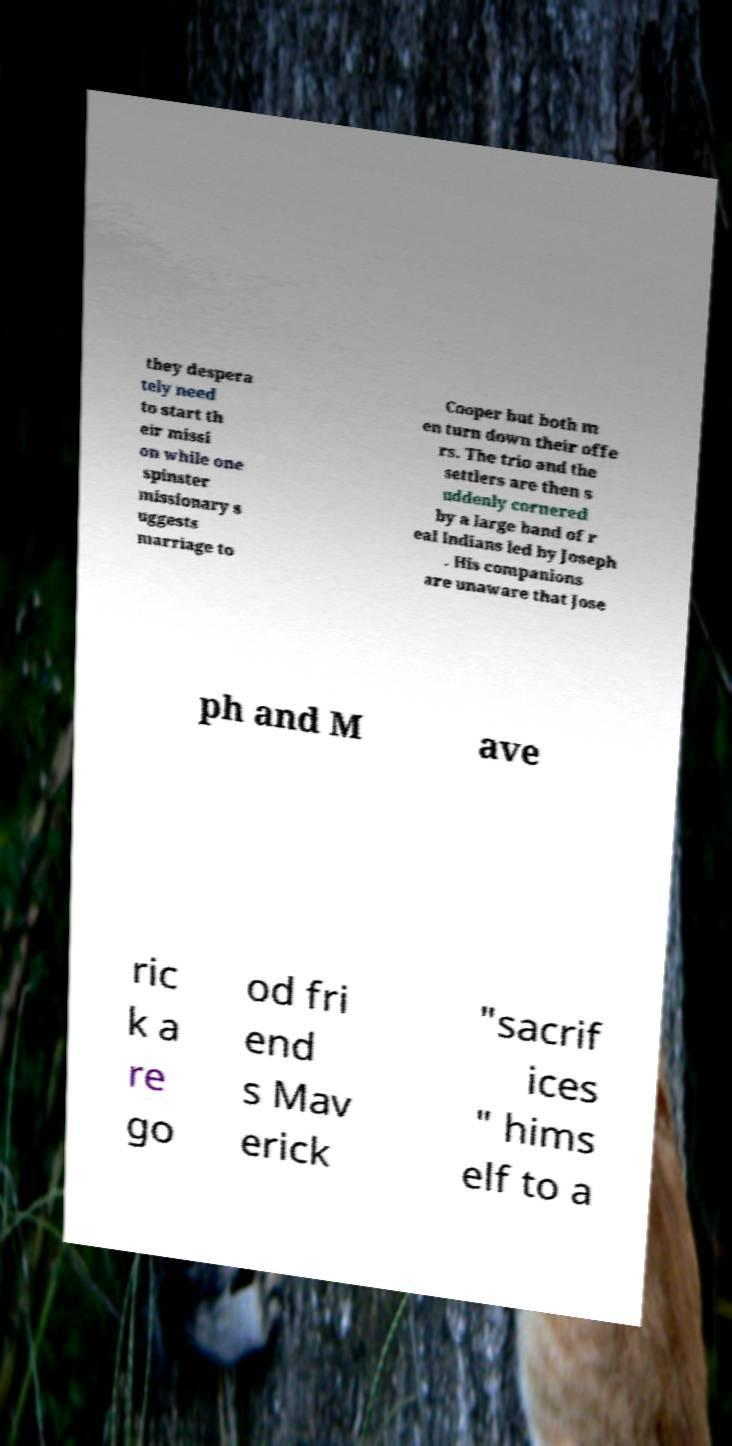What messages or text are displayed in this image? I need them in a readable, typed format. they despera tely need to start th eir missi on while one spinster missionary s uggests marriage to Cooper but both m en turn down their offe rs. The trio and the settlers are then s uddenly cornered by a large band of r eal Indians led by Joseph . His companions are unaware that Jose ph and M ave ric k a re go od fri end s Mav erick "sacrif ices " hims elf to a 